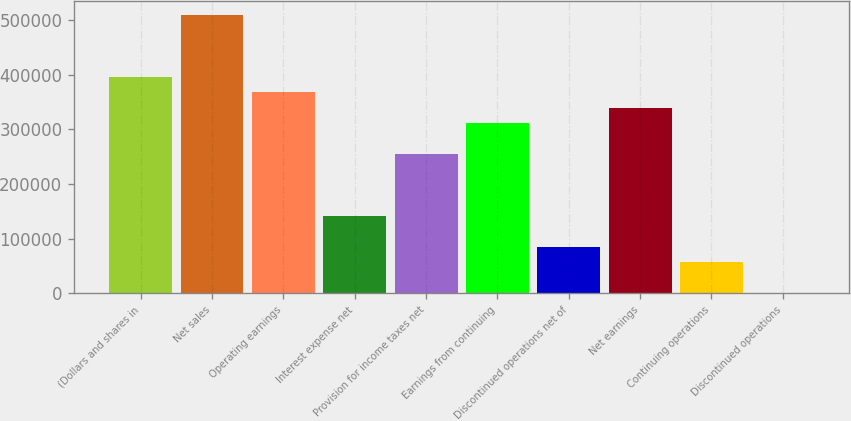Convert chart. <chart><loc_0><loc_0><loc_500><loc_500><bar_chart><fcel>(Dollars and shares in<fcel>Net sales<fcel>Operating earnings<fcel>Interest expense net<fcel>Provision for income taxes net<fcel>Earnings from continuing<fcel>Discontinued operations net of<fcel>Net earnings<fcel>Continuing operations<fcel>Discontinued operations<nl><fcel>396480<fcel>509760<fcel>368160<fcel>141600<fcel>254880<fcel>311520<fcel>84960.1<fcel>339840<fcel>56640.1<fcel>0.11<nl></chart> 